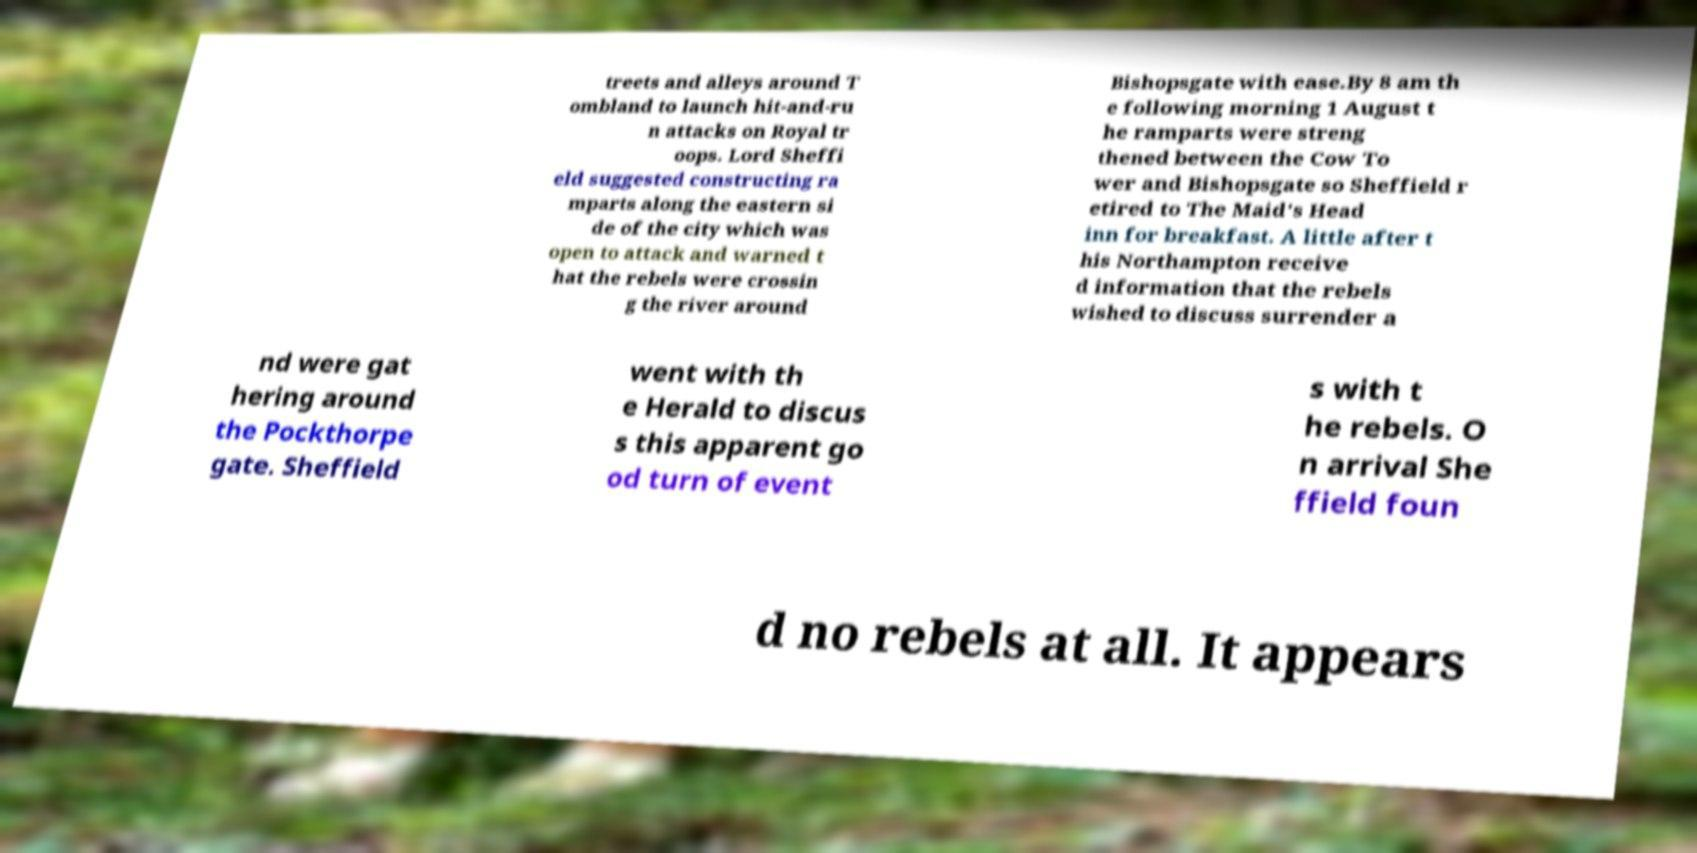Please read and relay the text visible in this image. What does it say? treets and alleys around T ombland to launch hit-and-ru n attacks on Royal tr oops. Lord Sheffi eld suggested constructing ra mparts along the eastern si de of the city which was open to attack and warned t hat the rebels were crossin g the river around Bishopsgate with ease.By 8 am th e following morning 1 August t he ramparts were streng thened between the Cow To wer and Bishopsgate so Sheffield r etired to The Maid's Head inn for breakfast. A little after t his Northampton receive d information that the rebels wished to discuss surrender a nd were gat hering around the Pockthorpe gate. Sheffield went with th e Herald to discus s this apparent go od turn of event s with t he rebels. O n arrival She ffield foun d no rebels at all. It appears 